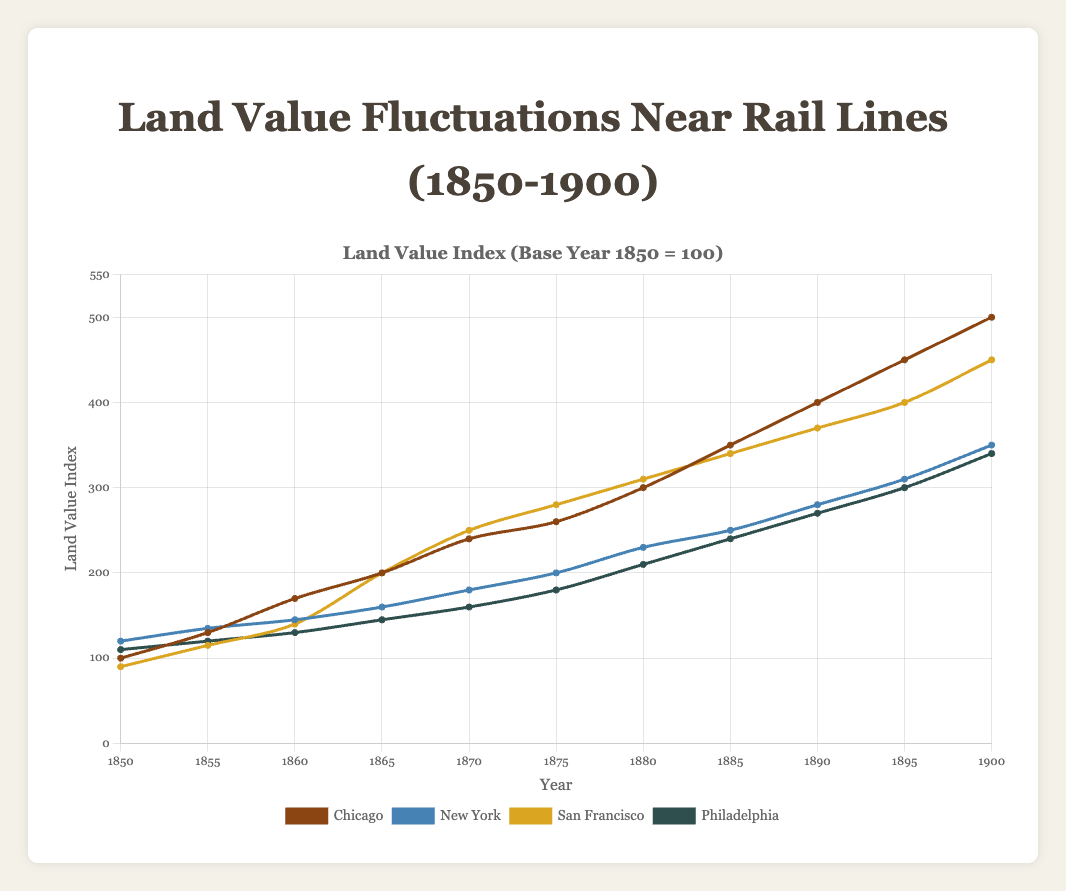Which city had the highest land value in 1900? In 1900, Chicago had a land value index of 500, New York had 350, San Francisco had 450, and Philadelphia had 340. The highest value is 500 in Chicago.
Answer: Chicago What is the difference in land value between New York and Philadelphia in 1870? In 1870, New York had a land value index of 180 and Philadelphia had 160. The difference is 180 - 160 = 20.
Answer: 20 During which year did San Francisco's land value equal Chicago's? In 1865, both San Francisco and Chicago had a land value index of 200.
Answer: 1865 Which city experienced the greatest increase in land value between 1850 and 1900? Chicago increased from 100 to 500, a gain of 400. New York increased from 120 to 350, a gain of 230. San Francisco increased from 90 to 450, a gain of 360. Philadelphia increased from 110 to 340, a gain of 230. The greatest increase is 400 by Chicago.
Answer: Chicago What was the average land value for Philadelphia from 1850 to 1900? The sum of Philadelphia's land value indices from 1850 to 1900 is 110 + 120 + 130 + 145 + 160 + 180 + 210 + 240 + 270 + 300 + 340 = 2205. There are 11 data points. The average is 2205 / 11 = 200.45.
Answer: 200.45 Which city had the lowest average land value from 1850 to 1900? Calculating averages: Chicago: 3100 / 11 = 281.82, New York: 2360 / 11 = 214.55, San Francisco: 2925 / 11 = 265.91, Philadelphia: 2205 / 11 = 200.45. The lowest average land value is for Philadelphia, 200.45.
Answer: Philadelphia In which period did Chicago's land value increase the most rapidly? Comparing period increases for Chicago: (1850-1855): 30, (1855-1860): 40, (1860-1865): 30, (1865-1870): 40, (1870-1875): 20, (1875-1880): 40, (1880-1885): 50, (1885-1890): 50, (1890-1895): 50, (1895-1900): 50. The most rapid increase was from 1880 to 1900.
Answer: 1880 to 1900 What year did New York's land value surpass 200? New York's land value was 200 in 1875 and increased to 230 in 1880. It surpassed 200 between 1875 and 1880.
Answer: 1880 By how much did San Francisco's land value index increase between 1860 and 1865? Between 1860 and 1865, San Francisco's land value increased from 140 to 200. The increase is 200 - 140 = 60.
Answer: 60 